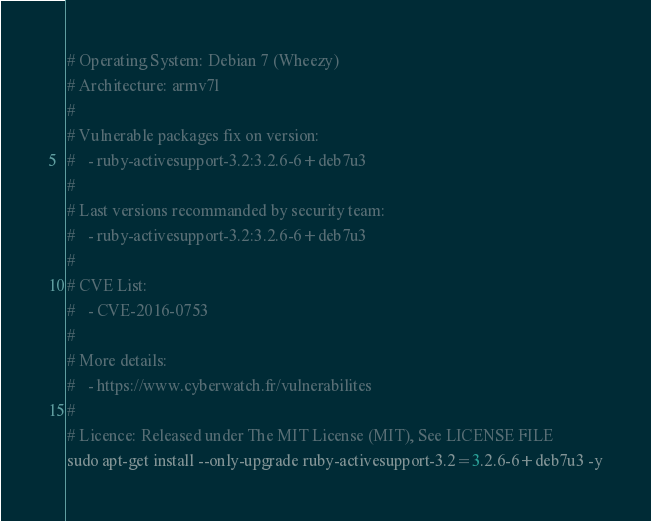Convert code to text. <code><loc_0><loc_0><loc_500><loc_500><_Bash_># Operating System: Debian 7 (Wheezy)
# Architecture: armv7l
#
# Vulnerable packages fix on version:
#   - ruby-activesupport-3.2:3.2.6-6+deb7u3
#
# Last versions recommanded by security team:
#   - ruby-activesupport-3.2:3.2.6-6+deb7u3
#
# CVE List:
#   - CVE-2016-0753
#
# More details:
#   - https://www.cyberwatch.fr/vulnerabilites
#
# Licence: Released under The MIT License (MIT), See LICENSE FILE
sudo apt-get install --only-upgrade ruby-activesupport-3.2=3.2.6-6+deb7u3 -y
</code> 